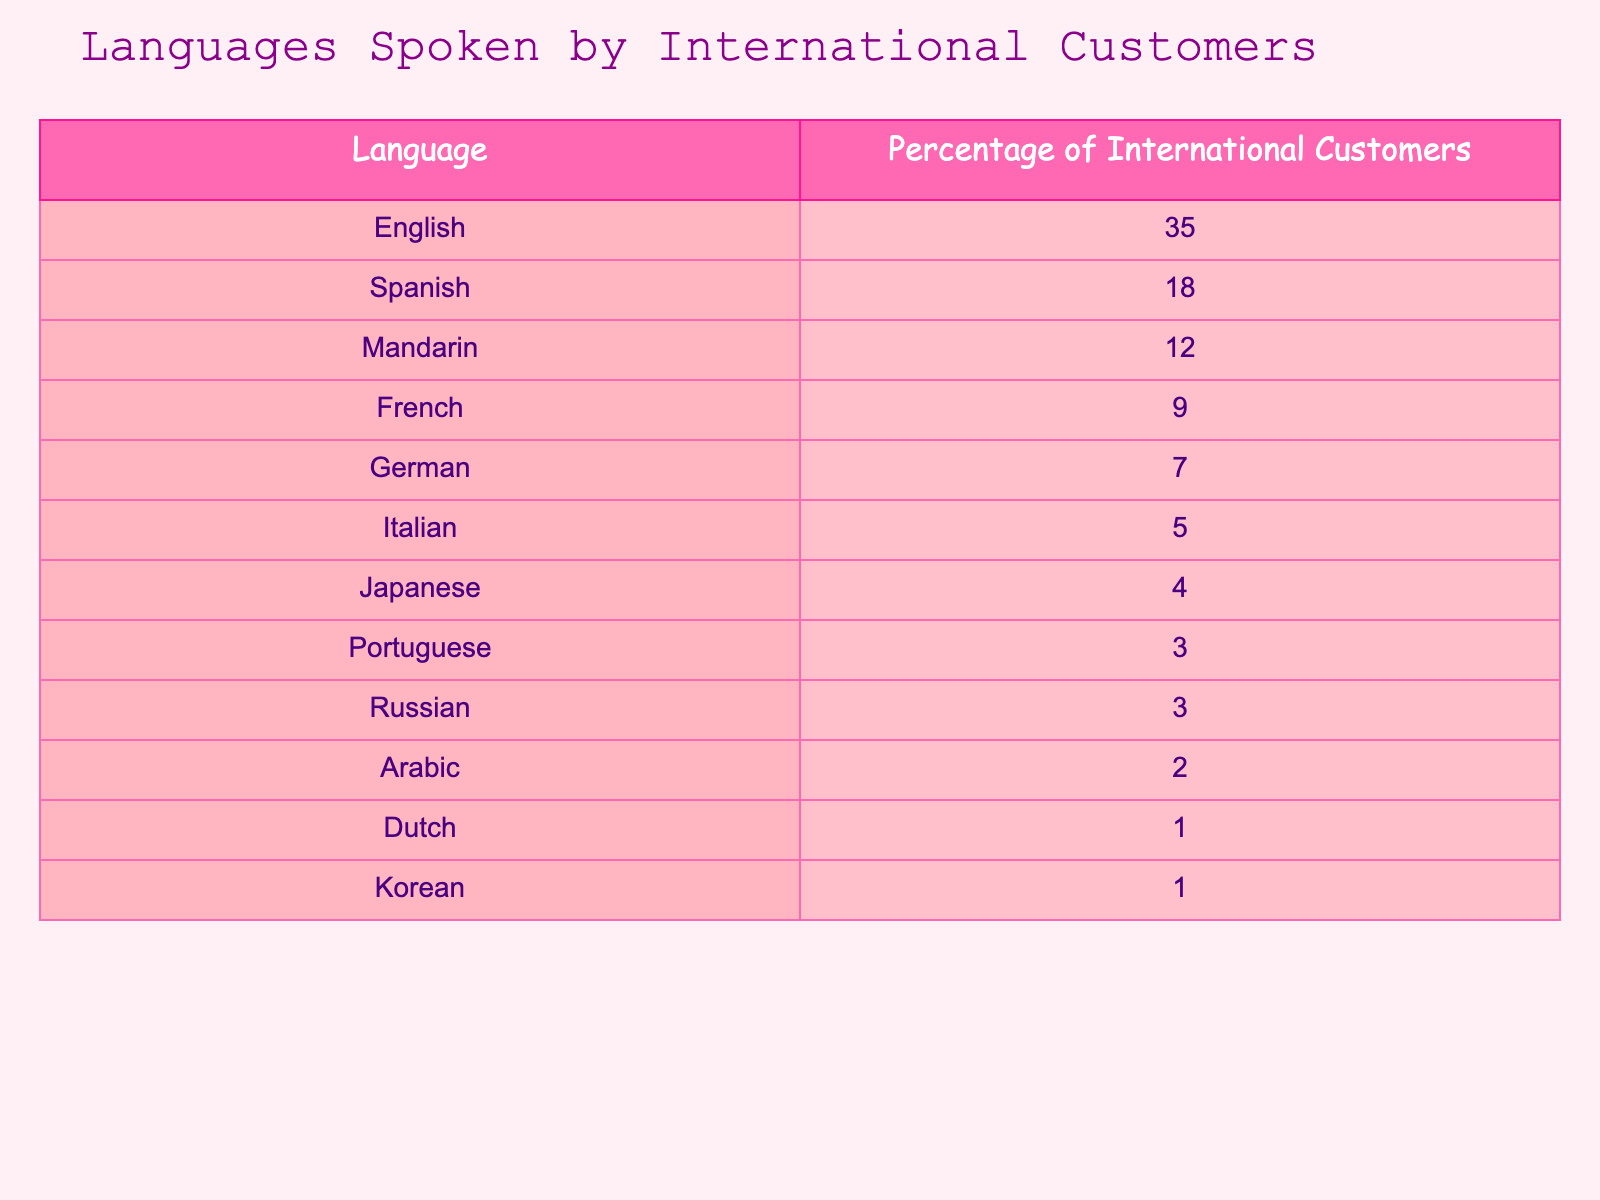What's the most common language spoken by international customers? The table clearly shows that English has the highest percentage of international customers speaking it at 35%.
Answer: English Which language is spoken by exactly 3% of international customers? According to the table, both Portuguese and Russian are listed with a percentage of 3% each.
Answer: Portuguese and Russian What is the total percentage of customers who speak Spanish and French combined? The percentage of Spanish is 18%, and French is 9%. Adding these together: 18 + 9 = 27%.
Answer: 27% Is the percentage of Italian customers higher or lower than that of Japanese customers? The table shows that Italian customers account for 5% while Japanese customers account for 4%. Since 5% is greater than 4%, it is higher.
Answer: Higher What percentage of international customers speak only English or Spanish? To find this, add the percentages of English (35%) and Spanish (18%): 35 + 18 = 53%.
Answer: 53% If we consider the top three languages spoken, what is their combined percentage? The top three languages and their percentages are English (35%), Spanish (18%), and Mandarin (12%). Summing these gives: 35 + 18 + 12 = 65%.
Answer: 65% Which languages are spoken by less than 5% of international customers? Referring to the table, we check the percentages: Italian (5%), Japanese (4%), Portuguese (3%), Russian (3%), Arabic (2%), Dutch (1%), Korean (1%). Only Japanese, Portuguese, Russian, Arabic, Dutch, and Korean are below 5%.
Answer: Japanese, Portuguese, Russian, Arabic, Dutch, Korean What is the difference in percentage between the customers who speak French and those who speak German? French has a percentage of 9% and German has 7%. The difference is calculated as 9 - 7 = 2%.
Answer: 2% How many languages have a percentage of 1% or more of international customers? By counting the rows in the table with 1% or more, we see 12 languages listed: English, Spanish, Mandarin, French, German, Italian, Japanese, Portuguese, Russian, Arabic, Dutch, and Korean.
Answer: 12 If the percentage of Arabic-speaking customers increased by 1%, what would the new value be? The current percentage of Arabic is 2%. Increasing it by 1% would give us 2 + 1 = 3%.
Answer: 3% 